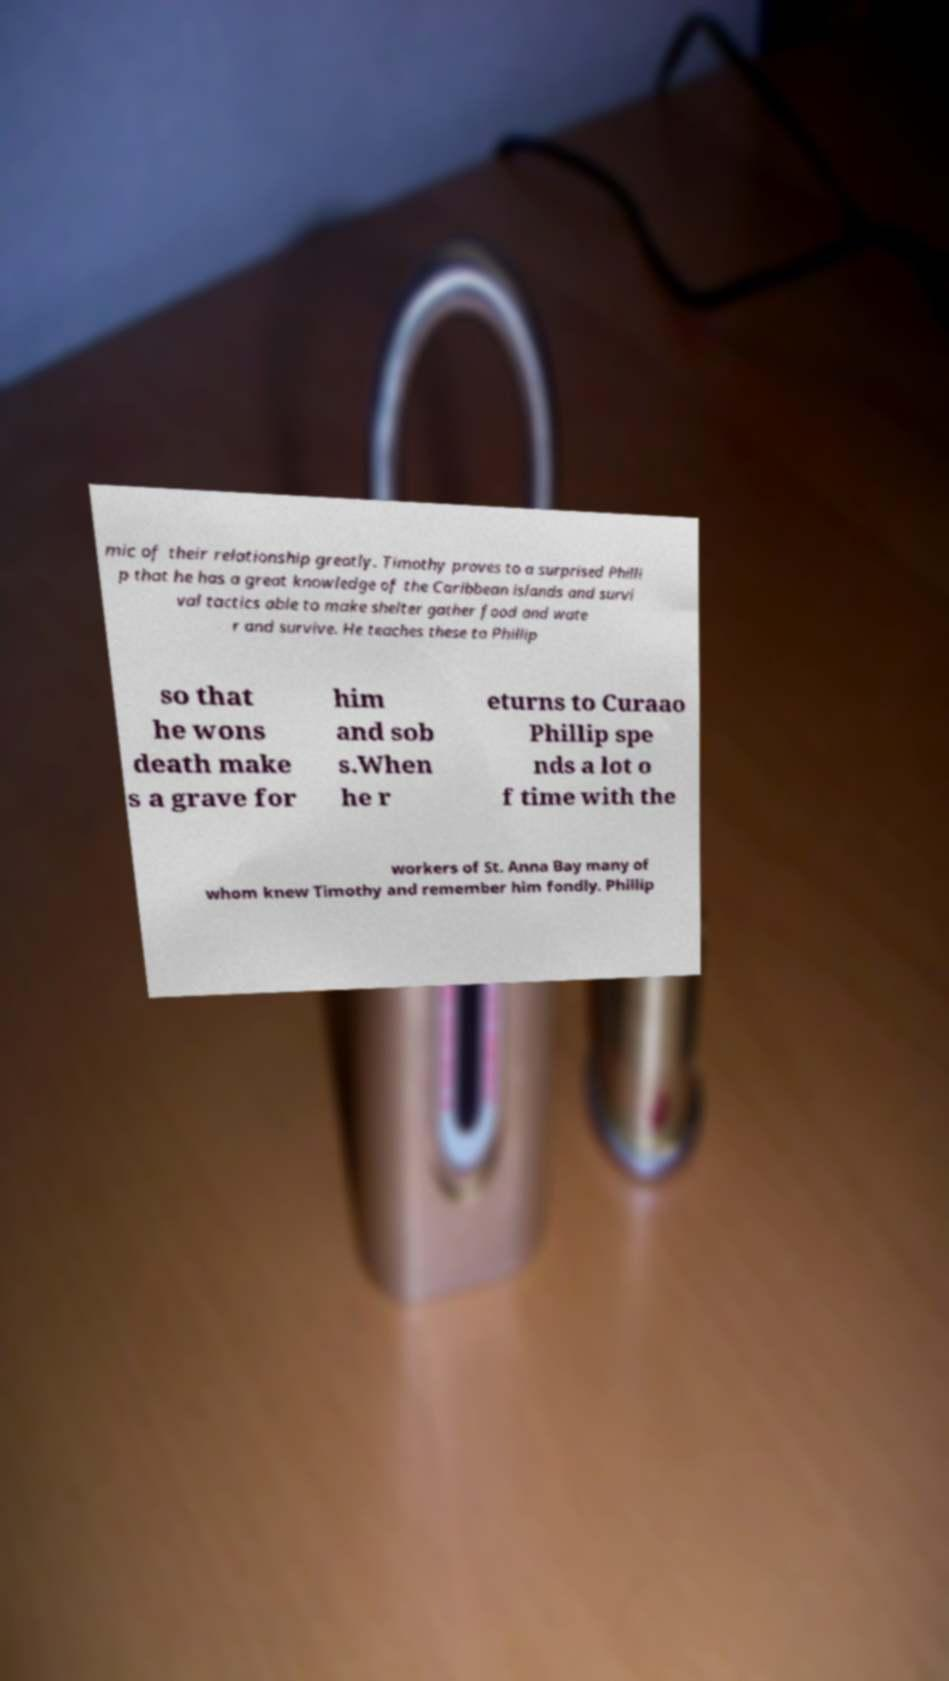Can you accurately transcribe the text from the provided image for me? mic of their relationship greatly. Timothy proves to a surprised Philli p that he has a great knowledge of the Caribbean islands and survi val tactics able to make shelter gather food and wate r and survive. He teaches these to Phillip so that he wons death make s a grave for him and sob s.When he r eturns to Curaao Phillip spe nds a lot o f time with the workers of St. Anna Bay many of whom knew Timothy and remember him fondly. Phillip 